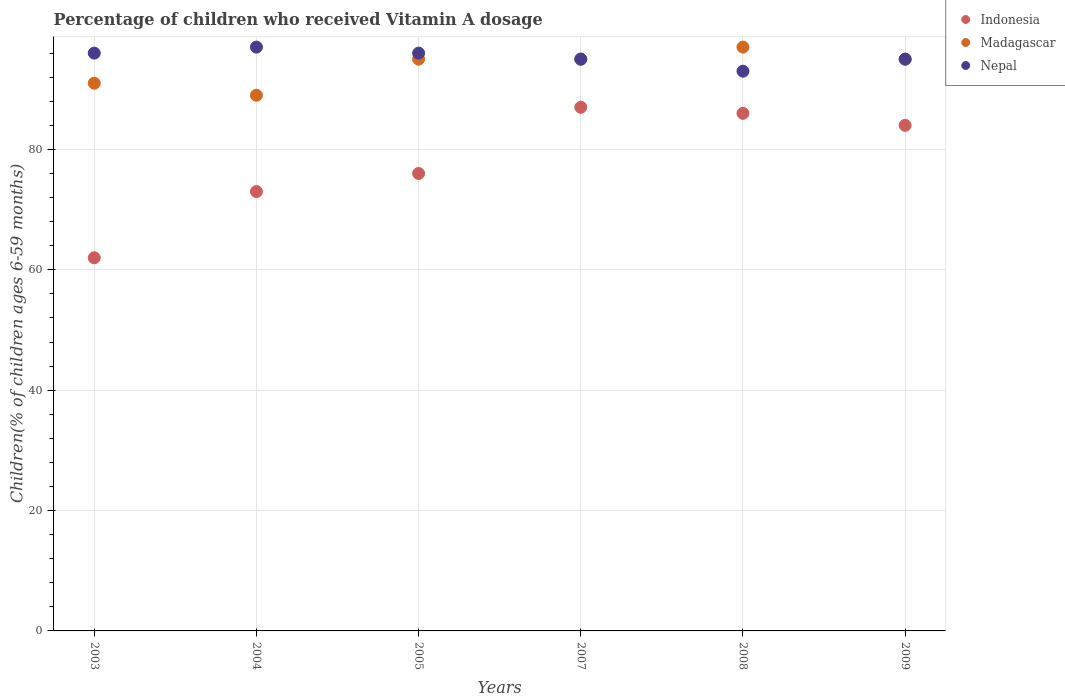How many different coloured dotlines are there?
Ensure brevity in your answer.  3. What is the percentage of children who received Vitamin A dosage in Nepal in 2005?
Provide a succinct answer. 96. Across all years, what is the maximum percentage of children who received Vitamin A dosage in Nepal?
Keep it short and to the point. 97. Across all years, what is the minimum percentage of children who received Vitamin A dosage in Madagascar?
Ensure brevity in your answer.  89. What is the total percentage of children who received Vitamin A dosage in Madagascar in the graph?
Give a very brief answer. 562. What is the difference between the percentage of children who received Vitamin A dosage in Madagascar in 2003 and that in 2005?
Give a very brief answer. -4. What is the difference between the percentage of children who received Vitamin A dosage in Indonesia in 2005 and the percentage of children who received Vitamin A dosage in Madagascar in 2009?
Make the answer very short. -19. What is the average percentage of children who received Vitamin A dosage in Nepal per year?
Provide a short and direct response. 95.33. What is the ratio of the percentage of children who received Vitamin A dosage in Nepal in 2003 to that in 2008?
Your answer should be very brief. 1.03. Is the percentage of children who received Vitamin A dosage in Madagascar in 2005 less than that in 2009?
Offer a very short reply. No. Is the sum of the percentage of children who received Vitamin A dosage in Madagascar in 2003 and 2005 greater than the maximum percentage of children who received Vitamin A dosage in Indonesia across all years?
Offer a terse response. Yes. Is it the case that in every year, the sum of the percentage of children who received Vitamin A dosage in Madagascar and percentage of children who received Vitamin A dosage in Indonesia  is greater than the percentage of children who received Vitamin A dosage in Nepal?
Your response must be concise. Yes. Does the percentage of children who received Vitamin A dosage in Indonesia monotonically increase over the years?
Your response must be concise. No. Is the percentage of children who received Vitamin A dosage in Indonesia strictly greater than the percentage of children who received Vitamin A dosage in Madagascar over the years?
Your answer should be very brief. No. Is the percentage of children who received Vitamin A dosage in Madagascar strictly less than the percentage of children who received Vitamin A dosage in Indonesia over the years?
Your answer should be very brief. No. How many dotlines are there?
Provide a succinct answer. 3. Are the values on the major ticks of Y-axis written in scientific E-notation?
Provide a short and direct response. No. Does the graph contain any zero values?
Your answer should be compact. No. Where does the legend appear in the graph?
Provide a succinct answer. Top right. What is the title of the graph?
Your answer should be very brief. Percentage of children who received Vitamin A dosage. What is the label or title of the X-axis?
Your response must be concise. Years. What is the label or title of the Y-axis?
Give a very brief answer. Children(% of children ages 6-59 months). What is the Children(% of children ages 6-59 months) of Indonesia in 2003?
Offer a terse response. 62. What is the Children(% of children ages 6-59 months) of Madagascar in 2003?
Ensure brevity in your answer.  91. What is the Children(% of children ages 6-59 months) of Nepal in 2003?
Ensure brevity in your answer.  96. What is the Children(% of children ages 6-59 months) in Indonesia in 2004?
Offer a terse response. 73. What is the Children(% of children ages 6-59 months) in Madagascar in 2004?
Your answer should be very brief. 89. What is the Children(% of children ages 6-59 months) of Nepal in 2004?
Offer a very short reply. 97. What is the Children(% of children ages 6-59 months) in Indonesia in 2005?
Ensure brevity in your answer.  76. What is the Children(% of children ages 6-59 months) in Madagascar in 2005?
Provide a short and direct response. 95. What is the Children(% of children ages 6-59 months) in Nepal in 2005?
Make the answer very short. 96. What is the Children(% of children ages 6-59 months) of Indonesia in 2007?
Your answer should be compact. 87. What is the Children(% of children ages 6-59 months) in Nepal in 2007?
Make the answer very short. 95. What is the Children(% of children ages 6-59 months) in Madagascar in 2008?
Keep it short and to the point. 97. What is the Children(% of children ages 6-59 months) of Nepal in 2008?
Your answer should be compact. 93. What is the Children(% of children ages 6-59 months) in Indonesia in 2009?
Give a very brief answer. 84. What is the Children(% of children ages 6-59 months) of Nepal in 2009?
Give a very brief answer. 95. Across all years, what is the maximum Children(% of children ages 6-59 months) of Indonesia?
Your answer should be very brief. 87. Across all years, what is the maximum Children(% of children ages 6-59 months) of Madagascar?
Give a very brief answer. 97. Across all years, what is the maximum Children(% of children ages 6-59 months) in Nepal?
Give a very brief answer. 97. Across all years, what is the minimum Children(% of children ages 6-59 months) in Madagascar?
Offer a very short reply. 89. Across all years, what is the minimum Children(% of children ages 6-59 months) in Nepal?
Keep it short and to the point. 93. What is the total Children(% of children ages 6-59 months) of Indonesia in the graph?
Keep it short and to the point. 468. What is the total Children(% of children ages 6-59 months) in Madagascar in the graph?
Provide a short and direct response. 562. What is the total Children(% of children ages 6-59 months) of Nepal in the graph?
Your answer should be compact. 572. What is the difference between the Children(% of children ages 6-59 months) in Madagascar in 2003 and that in 2004?
Your answer should be compact. 2. What is the difference between the Children(% of children ages 6-59 months) in Madagascar in 2003 and that in 2005?
Give a very brief answer. -4. What is the difference between the Children(% of children ages 6-59 months) of Nepal in 2003 and that in 2005?
Make the answer very short. 0. What is the difference between the Children(% of children ages 6-59 months) in Madagascar in 2003 and that in 2007?
Make the answer very short. -4. What is the difference between the Children(% of children ages 6-59 months) of Nepal in 2003 and that in 2009?
Provide a succinct answer. 1. What is the difference between the Children(% of children ages 6-59 months) in Madagascar in 2004 and that in 2005?
Your response must be concise. -6. What is the difference between the Children(% of children ages 6-59 months) in Indonesia in 2004 and that in 2007?
Your answer should be compact. -14. What is the difference between the Children(% of children ages 6-59 months) of Madagascar in 2004 and that in 2007?
Provide a succinct answer. -6. What is the difference between the Children(% of children ages 6-59 months) of Madagascar in 2004 and that in 2008?
Provide a succinct answer. -8. What is the difference between the Children(% of children ages 6-59 months) in Nepal in 2004 and that in 2008?
Give a very brief answer. 4. What is the difference between the Children(% of children ages 6-59 months) of Indonesia in 2004 and that in 2009?
Ensure brevity in your answer.  -11. What is the difference between the Children(% of children ages 6-59 months) in Madagascar in 2004 and that in 2009?
Provide a short and direct response. -6. What is the difference between the Children(% of children ages 6-59 months) in Nepal in 2004 and that in 2009?
Make the answer very short. 2. What is the difference between the Children(% of children ages 6-59 months) in Indonesia in 2005 and that in 2007?
Ensure brevity in your answer.  -11. What is the difference between the Children(% of children ages 6-59 months) of Nepal in 2005 and that in 2008?
Ensure brevity in your answer.  3. What is the difference between the Children(% of children ages 6-59 months) of Indonesia in 2005 and that in 2009?
Provide a short and direct response. -8. What is the difference between the Children(% of children ages 6-59 months) of Madagascar in 2007 and that in 2008?
Your response must be concise. -2. What is the difference between the Children(% of children ages 6-59 months) of Nepal in 2007 and that in 2008?
Make the answer very short. 2. What is the difference between the Children(% of children ages 6-59 months) in Indonesia in 2007 and that in 2009?
Ensure brevity in your answer.  3. What is the difference between the Children(% of children ages 6-59 months) in Nepal in 2007 and that in 2009?
Offer a terse response. 0. What is the difference between the Children(% of children ages 6-59 months) in Indonesia in 2008 and that in 2009?
Offer a terse response. 2. What is the difference between the Children(% of children ages 6-59 months) of Madagascar in 2008 and that in 2009?
Offer a very short reply. 2. What is the difference between the Children(% of children ages 6-59 months) of Nepal in 2008 and that in 2009?
Offer a very short reply. -2. What is the difference between the Children(% of children ages 6-59 months) in Indonesia in 2003 and the Children(% of children ages 6-59 months) in Nepal in 2004?
Ensure brevity in your answer.  -35. What is the difference between the Children(% of children ages 6-59 months) of Indonesia in 2003 and the Children(% of children ages 6-59 months) of Madagascar in 2005?
Ensure brevity in your answer.  -33. What is the difference between the Children(% of children ages 6-59 months) in Indonesia in 2003 and the Children(% of children ages 6-59 months) in Nepal in 2005?
Ensure brevity in your answer.  -34. What is the difference between the Children(% of children ages 6-59 months) of Madagascar in 2003 and the Children(% of children ages 6-59 months) of Nepal in 2005?
Your response must be concise. -5. What is the difference between the Children(% of children ages 6-59 months) of Indonesia in 2003 and the Children(% of children ages 6-59 months) of Madagascar in 2007?
Make the answer very short. -33. What is the difference between the Children(% of children ages 6-59 months) of Indonesia in 2003 and the Children(% of children ages 6-59 months) of Nepal in 2007?
Provide a succinct answer. -33. What is the difference between the Children(% of children ages 6-59 months) of Madagascar in 2003 and the Children(% of children ages 6-59 months) of Nepal in 2007?
Offer a terse response. -4. What is the difference between the Children(% of children ages 6-59 months) in Indonesia in 2003 and the Children(% of children ages 6-59 months) in Madagascar in 2008?
Keep it short and to the point. -35. What is the difference between the Children(% of children ages 6-59 months) in Indonesia in 2003 and the Children(% of children ages 6-59 months) in Nepal in 2008?
Provide a short and direct response. -31. What is the difference between the Children(% of children ages 6-59 months) in Indonesia in 2003 and the Children(% of children ages 6-59 months) in Madagascar in 2009?
Your response must be concise. -33. What is the difference between the Children(% of children ages 6-59 months) of Indonesia in 2003 and the Children(% of children ages 6-59 months) of Nepal in 2009?
Your answer should be very brief. -33. What is the difference between the Children(% of children ages 6-59 months) in Madagascar in 2004 and the Children(% of children ages 6-59 months) in Nepal in 2005?
Keep it short and to the point. -7. What is the difference between the Children(% of children ages 6-59 months) of Indonesia in 2004 and the Children(% of children ages 6-59 months) of Madagascar in 2007?
Ensure brevity in your answer.  -22. What is the difference between the Children(% of children ages 6-59 months) in Indonesia in 2004 and the Children(% of children ages 6-59 months) in Madagascar in 2008?
Provide a succinct answer. -24. What is the difference between the Children(% of children ages 6-59 months) of Indonesia in 2004 and the Children(% of children ages 6-59 months) of Madagascar in 2009?
Make the answer very short. -22. What is the difference between the Children(% of children ages 6-59 months) of Indonesia in 2004 and the Children(% of children ages 6-59 months) of Nepal in 2009?
Make the answer very short. -22. What is the difference between the Children(% of children ages 6-59 months) of Madagascar in 2004 and the Children(% of children ages 6-59 months) of Nepal in 2009?
Offer a terse response. -6. What is the difference between the Children(% of children ages 6-59 months) in Indonesia in 2005 and the Children(% of children ages 6-59 months) in Nepal in 2007?
Your answer should be compact. -19. What is the difference between the Children(% of children ages 6-59 months) in Madagascar in 2005 and the Children(% of children ages 6-59 months) in Nepal in 2007?
Your answer should be compact. 0. What is the difference between the Children(% of children ages 6-59 months) of Madagascar in 2005 and the Children(% of children ages 6-59 months) of Nepal in 2008?
Provide a short and direct response. 2. What is the difference between the Children(% of children ages 6-59 months) in Indonesia in 2005 and the Children(% of children ages 6-59 months) in Madagascar in 2009?
Give a very brief answer. -19. What is the difference between the Children(% of children ages 6-59 months) of Madagascar in 2005 and the Children(% of children ages 6-59 months) of Nepal in 2009?
Give a very brief answer. 0. What is the difference between the Children(% of children ages 6-59 months) of Indonesia in 2007 and the Children(% of children ages 6-59 months) of Madagascar in 2008?
Give a very brief answer. -10. What is the difference between the Children(% of children ages 6-59 months) in Indonesia in 2007 and the Children(% of children ages 6-59 months) in Madagascar in 2009?
Provide a succinct answer. -8. What is the difference between the Children(% of children ages 6-59 months) of Indonesia in 2008 and the Children(% of children ages 6-59 months) of Madagascar in 2009?
Offer a very short reply. -9. What is the difference between the Children(% of children ages 6-59 months) of Indonesia in 2008 and the Children(% of children ages 6-59 months) of Nepal in 2009?
Offer a terse response. -9. What is the difference between the Children(% of children ages 6-59 months) in Madagascar in 2008 and the Children(% of children ages 6-59 months) in Nepal in 2009?
Provide a short and direct response. 2. What is the average Children(% of children ages 6-59 months) of Madagascar per year?
Your response must be concise. 93.67. What is the average Children(% of children ages 6-59 months) in Nepal per year?
Ensure brevity in your answer.  95.33. In the year 2003, what is the difference between the Children(% of children ages 6-59 months) in Indonesia and Children(% of children ages 6-59 months) in Madagascar?
Provide a succinct answer. -29. In the year 2003, what is the difference between the Children(% of children ages 6-59 months) in Indonesia and Children(% of children ages 6-59 months) in Nepal?
Your response must be concise. -34. In the year 2004, what is the difference between the Children(% of children ages 6-59 months) in Madagascar and Children(% of children ages 6-59 months) in Nepal?
Make the answer very short. -8. In the year 2007, what is the difference between the Children(% of children ages 6-59 months) of Indonesia and Children(% of children ages 6-59 months) of Madagascar?
Make the answer very short. -8. In the year 2008, what is the difference between the Children(% of children ages 6-59 months) of Indonesia and Children(% of children ages 6-59 months) of Nepal?
Ensure brevity in your answer.  -7. In the year 2008, what is the difference between the Children(% of children ages 6-59 months) in Madagascar and Children(% of children ages 6-59 months) in Nepal?
Your answer should be very brief. 4. In the year 2009, what is the difference between the Children(% of children ages 6-59 months) in Indonesia and Children(% of children ages 6-59 months) in Madagascar?
Ensure brevity in your answer.  -11. In the year 2009, what is the difference between the Children(% of children ages 6-59 months) in Indonesia and Children(% of children ages 6-59 months) in Nepal?
Your answer should be compact. -11. In the year 2009, what is the difference between the Children(% of children ages 6-59 months) in Madagascar and Children(% of children ages 6-59 months) in Nepal?
Your response must be concise. 0. What is the ratio of the Children(% of children ages 6-59 months) of Indonesia in 2003 to that in 2004?
Provide a short and direct response. 0.85. What is the ratio of the Children(% of children ages 6-59 months) of Madagascar in 2003 to that in 2004?
Your response must be concise. 1.02. What is the ratio of the Children(% of children ages 6-59 months) in Indonesia in 2003 to that in 2005?
Keep it short and to the point. 0.82. What is the ratio of the Children(% of children ages 6-59 months) in Madagascar in 2003 to that in 2005?
Your answer should be very brief. 0.96. What is the ratio of the Children(% of children ages 6-59 months) in Nepal in 2003 to that in 2005?
Offer a very short reply. 1. What is the ratio of the Children(% of children ages 6-59 months) of Indonesia in 2003 to that in 2007?
Provide a succinct answer. 0.71. What is the ratio of the Children(% of children ages 6-59 months) of Madagascar in 2003 to that in 2007?
Your answer should be compact. 0.96. What is the ratio of the Children(% of children ages 6-59 months) in Nepal in 2003 to that in 2007?
Provide a short and direct response. 1.01. What is the ratio of the Children(% of children ages 6-59 months) in Indonesia in 2003 to that in 2008?
Give a very brief answer. 0.72. What is the ratio of the Children(% of children ages 6-59 months) in Madagascar in 2003 to that in 2008?
Provide a succinct answer. 0.94. What is the ratio of the Children(% of children ages 6-59 months) of Nepal in 2003 to that in 2008?
Your response must be concise. 1.03. What is the ratio of the Children(% of children ages 6-59 months) of Indonesia in 2003 to that in 2009?
Your answer should be compact. 0.74. What is the ratio of the Children(% of children ages 6-59 months) in Madagascar in 2003 to that in 2009?
Your answer should be very brief. 0.96. What is the ratio of the Children(% of children ages 6-59 months) in Nepal in 2003 to that in 2009?
Your answer should be compact. 1.01. What is the ratio of the Children(% of children ages 6-59 months) of Indonesia in 2004 to that in 2005?
Keep it short and to the point. 0.96. What is the ratio of the Children(% of children ages 6-59 months) of Madagascar in 2004 to that in 2005?
Make the answer very short. 0.94. What is the ratio of the Children(% of children ages 6-59 months) in Nepal in 2004 to that in 2005?
Provide a short and direct response. 1.01. What is the ratio of the Children(% of children ages 6-59 months) of Indonesia in 2004 to that in 2007?
Give a very brief answer. 0.84. What is the ratio of the Children(% of children ages 6-59 months) in Madagascar in 2004 to that in 2007?
Your answer should be very brief. 0.94. What is the ratio of the Children(% of children ages 6-59 months) of Nepal in 2004 to that in 2007?
Ensure brevity in your answer.  1.02. What is the ratio of the Children(% of children ages 6-59 months) of Indonesia in 2004 to that in 2008?
Ensure brevity in your answer.  0.85. What is the ratio of the Children(% of children ages 6-59 months) of Madagascar in 2004 to that in 2008?
Your answer should be very brief. 0.92. What is the ratio of the Children(% of children ages 6-59 months) of Nepal in 2004 to that in 2008?
Make the answer very short. 1.04. What is the ratio of the Children(% of children ages 6-59 months) of Indonesia in 2004 to that in 2009?
Make the answer very short. 0.87. What is the ratio of the Children(% of children ages 6-59 months) in Madagascar in 2004 to that in 2009?
Your response must be concise. 0.94. What is the ratio of the Children(% of children ages 6-59 months) in Nepal in 2004 to that in 2009?
Your response must be concise. 1.02. What is the ratio of the Children(% of children ages 6-59 months) in Indonesia in 2005 to that in 2007?
Offer a very short reply. 0.87. What is the ratio of the Children(% of children ages 6-59 months) in Nepal in 2005 to that in 2007?
Your answer should be compact. 1.01. What is the ratio of the Children(% of children ages 6-59 months) in Indonesia in 2005 to that in 2008?
Provide a short and direct response. 0.88. What is the ratio of the Children(% of children ages 6-59 months) in Madagascar in 2005 to that in 2008?
Your response must be concise. 0.98. What is the ratio of the Children(% of children ages 6-59 months) of Nepal in 2005 to that in 2008?
Make the answer very short. 1.03. What is the ratio of the Children(% of children ages 6-59 months) of Indonesia in 2005 to that in 2009?
Offer a terse response. 0.9. What is the ratio of the Children(% of children ages 6-59 months) of Nepal in 2005 to that in 2009?
Your response must be concise. 1.01. What is the ratio of the Children(% of children ages 6-59 months) of Indonesia in 2007 to that in 2008?
Your answer should be compact. 1.01. What is the ratio of the Children(% of children ages 6-59 months) of Madagascar in 2007 to that in 2008?
Your response must be concise. 0.98. What is the ratio of the Children(% of children ages 6-59 months) in Nepal in 2007 to that in 2008?
Provide a short and direct response. 1.02. What is the ratio of the Children(% of children ages 6-59 months) of Indonesia in 2007 to that in 2009?
Provide a short and direct response. 1.04. What is the ratio of the Children(% of children ages 6-59 months) of Nepal in 2007 to that in 2009?
Your answer should be compact. 1. What is the ratio of the Children(% of children ages 6-59 months) of Indonesia in 2008 to that in 2009?
Your answer should be very brief. 1.02. What is the ratio of the Children(% of children ages 6-59 months) of Madagascar in 2008 to that in 2009?
Your answer should be compact. 1.02. What is the ratio of the Children(% of children ages 6-59 months) of Nepal in 2008 to that in 2009?
Your response must be concise. 0.98. What is the difference between the highest and the second highest Children(% of children ages 6-59 months) in Indonesia?
Provide a succinct answer. 1. What is the difference between the highest and the lowest Children(% of children ages 6-59 months) of Madagascar?
Provide a succinct answer. 8. 